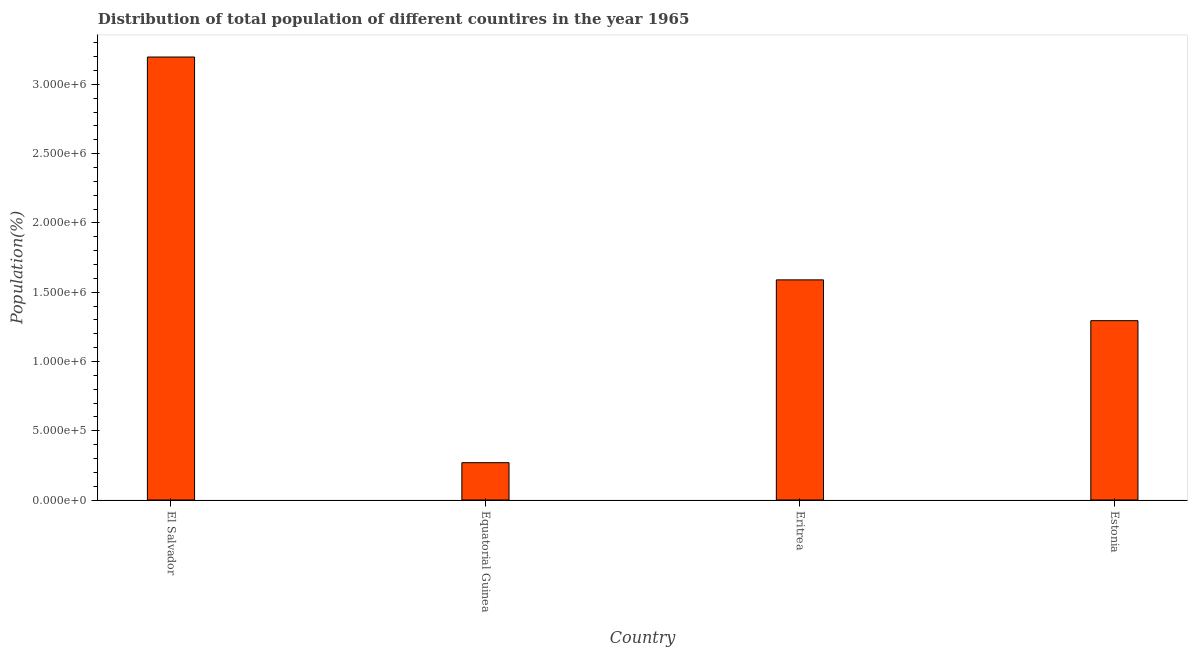Does the graph contain any zero values?
Offer a very short reply. No. Does the graph contain grids?
Your answer should be very brief. No. What is the title of the graph?
Your answer should be compact. Distribution of total population of different countires in the year 1965. What is the label or title of the X-axis?
Offer a terse response. Country. What is the label or title of the Y-axis?
Offer a very short reply. Population(%). What is the population in Equatorial Guinea?
Keep it short and to the point. 2.69e+05. Across all countries, what is the maximum population?
Make the answer very short. 3.20e+06. Across all countries, what is the minimum population?
Make the answer very short. 2.69e+05. In which country was the population maximum?
Offer a very short reply. El Salvador. In which country was the population minimum?
Keep it short and to the point. Equatorial Guinea. What is the sum of the population?
Your answer should be very brief. 6.35e+06. What is the difference between the population in Eritrea and Estonia?
Offer a terse response. 2.95e+05. What is the average population per country?
Your response must be concise. 1.59e+06. What is the median population?
Ensure brevity in your answer.  1.44e+06. What is the ratio of the population in Eritrea to that in Estonia?
Provide a short and direct response. 1.23. Is the population in El Salvador less than that in Equatorial Guinea?
Keep it short and to the point. No. Is the difference between the population in Equatorial Guinea and Eritrea greater than the difference between any two countries?
Offer a terse response. No. What is the difference between the highest and the second highest population?
Offer a terse response. 1.61e+06. What is the difference between the highest and the lowest population?
Your answer should be compact. 2.93e+06. In how many countries, is the population greater than the average population taken over all countries?
Make the answer very short. 2. How many bars are there?
Give a very brief answer. 4. Are the values on the major ticks of Y-axis written in scientific E-notation?
Your answer should be compact. Yes. What is the Population(%) in El Salvador?
Your answer should be compact. 3.20e+06. What is the Population(%) in Equatorial Guinea?
Keep it short and to the point. 2.69e+05. What is the Population(%) in Eritrea?
Provide a short and direct response. 1.59e+06. What is the Population(%) in Estonia?
Your answer should be compact. 1.29e+06. What is the difference between the Population(%) in El Salvador and Equatorial Guinea?
Your answer should be very brief. 2.93e+06. What is the difference between the Population(%) in El Salvador and Eritrea?
Give a very brief answer. 1.61e+06. What is the difference between the Population(%) in El Salvador and Estonia?
Keep it short and to the point. 1.90e+06. What is the difference between the Population(%) in Equatorial Guinea and Eritrea?
Provide a short and direct response. -1.32e+06. What is the difference between the Population(%) in Equatorial Guinea and Estonia?
Keep it short and to the point. -1.03e+06. What is the difference between the Population(%) in Eritrea and Estonia?
Provide a short and direct response. 2.95e+05. What is the ratio of the Population(%) in El Salvador to that in Equatorial Guinea?
Your answer should be very brief. 11.87. What is the ratio of the Population(%) in El Salvador to that in Eritrea?
Keep it short and to the point. 2.01. What is the ratio of the Population(%) in El Salvador to that in Estonia?
Your response must be concise. 2.47. What is the ratio of the Population(%) in Equatorial Guinea to that in Eritrea?
Offer a terse response. 0.17. What is the ratio of the Population(%) in Equatorial Guinea to that in Estonia?
Your answer should be compact. 0.21. What is the ratio of the Population(%) in Eritrea to that in Estonia?
Give a very brief answer. 1.23. 